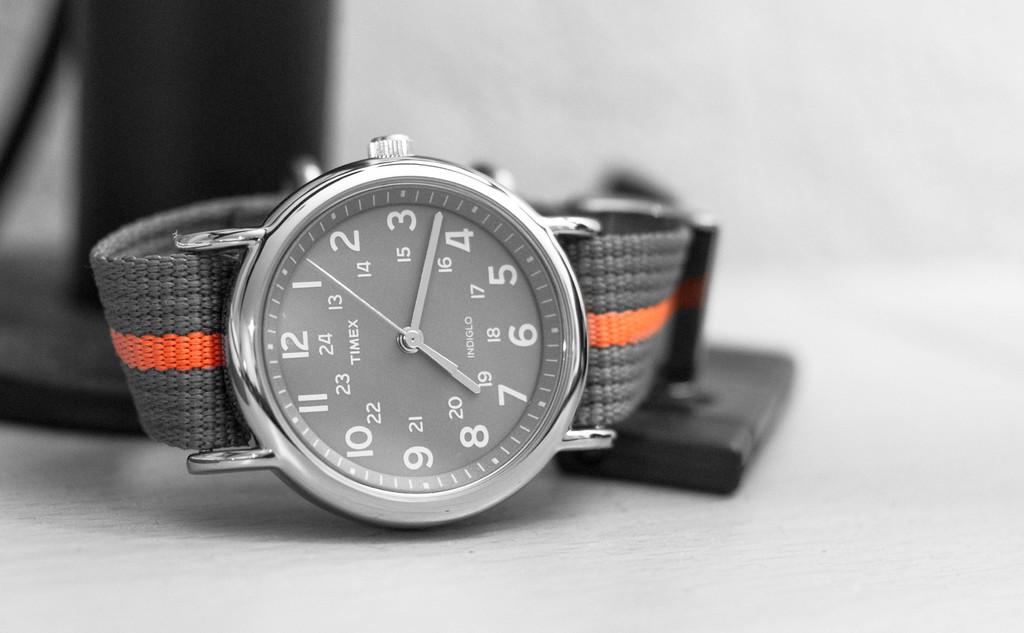What time does the watch show?
Make the answer very short. 7:18. What does the number say below the 12?
Your response must be concise. 24. 